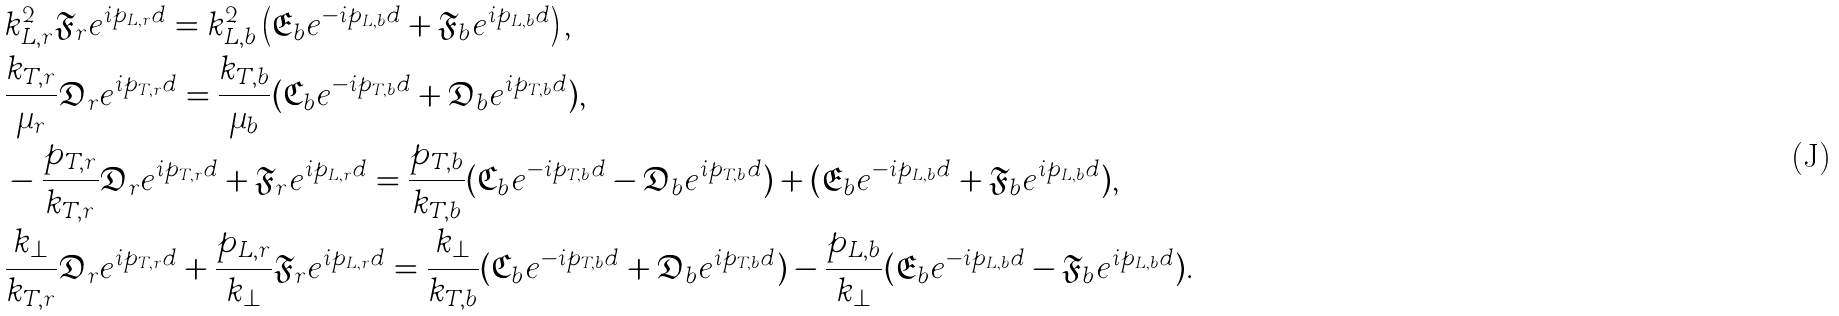<formula> <loc_0><loc_0><loc_500><loc_500>& k _ { L , r } ^ { 2 } \mathfrak { F } _ { r } e ^ { i p _ { L , r } d } = k _ { L , b } ^ { 2 } \left ( \mathfrak { E } _ { b } e ^ { - i p _ { L , b } d } + \mathfrak { F } _ { b } e ^ { i p _ { L , b } d } \right ) , \\ & \frac { k _ { T , r } } { \mu _ { r } } \mathfrak { D } _ { r } e ^ { i p _ { T , r } d } = \frac { k _ { T , b } } { \mu _ { b } } ( \mathfrak { C } _ { b } e ^ { - i p _ { T , b } d } + \mathfrak { D } _ { b } e ^ { i p _ { T , b } d } ) , \\ & - \frac { p _ { T , r } } { k _ { T , r } } \mathfrak { D } _ { r } e ^ { i p _ { T , r } d } + \mathfrak { F } _ { r } e ^ { i p _ { L , r } d } = \frac { p _ { T , b } } { k _ { T , b } } ( \mathfrak { C } _ { b } e ^ { - i p _ { T , b } d } - \mathfrak { D } _ { b } e ^ { i p _ { T , b } d } ) + ( \mathfrak { E } _ { b } e ^ { - i p _ { L , b } d } + \mathfrak { F } _ { b } e ^ { i p _ { L , b } d } ) , \\ & \frac { k _ { \perp } } { k _ { T , r } } \mathfrak { D } _ { r } e ^ { i p _ { T , r } d } + \frac { p _ { L , r } } { k _ { \perp } } \mathfrak { F } _ { r } e ^ { i p _ { L , r } d } = \frac { k _ { \perp } } { k _ { T , b } } ( \mathfrak { C } _ { b } e ^ { - i p _ { T , b } d } + \mathfrak { D } _ { b } e ^ { i p _ { T , b } d } ) - \frac { p _ { L , b } } { k _ { \perp } } ( \mathfrak { E } _ { b } e ^ { - i p _ { L , b } d } - \mathfrak { F } _ { b } e ^ { i p _ { L , b } d } ) .</formula> 